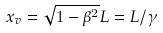Convert formula to latex. <formula><loc_0><loc_0><loc_500><loc_500>x _ { v } = \sqrt { 1 - \beta ^ { 2 } } L = L / \gamma</formula> 